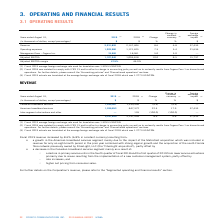According to Cogeco's financial document, What was the 2019 exchange rate? According to the financial document, 1.3255 USD/CDN.. The relevant text states: "age foreign exchange rate used for translation was 1.3255 USD/CDN...." Also, What was the adjusted EBITDA margin in 2019? According to the financial document, 47.5%. The relevant text states: "Adjusted EBITDA margin 47.5% 46.9%..." Also, What was the exchange rate in 2018? According to the financial document, 1.2773 USD/CDN.. The relevant text states: "age foreign exchange rate of fiscal 2018 which was 1.2773 USD/CDN...." Also, can you calculate: What is the increase / (decrease) in revenue from 2018 to 2019? Based on the calculation: 2,331,820 - 2,147,404, the result is 184416 (in thousands). This is based on the information: "Revenue 2,331,820 2,147,404 8.6 6.8 37,433 Revenue 2,331,820 2,147,404 8.6 6.8 37,433..." The key data points involved are: 2,147,404, 2,331,820. Also, can you calculate: What was the average operating expenses between 2018 and 2019? To answer this question, I need to perform calculations using the financial data. The calculation is: (1,203,980 + 1,121,625) / 2, which equals 1162802.5 (in thousands). This is based on the information: "Operating expenses 1,203,980 1,121,625 7.3 5.4 21,636 Operating expenses 1,203,980 1,121,625 7.3 5.4 21,636..." The key data points involved are: 1,121,625, 1,203,980. Also, can you calculate: What was the increase / (decrease) in the Adjusted EBITDA from 2018 to 2019? Based on the calculation: 1,107,940 - 1,006,818, the result is 101122 (in thousands). This is based on the information: "Adjusted EBITDA 1,107,940 1,006,818 10.0 8.5 15,797 Adjusted EBITDA 1,107,940 1,006,818 10.0 8.5 15,797..." The key data points involved are: 1,006,818, 1,107,940. 